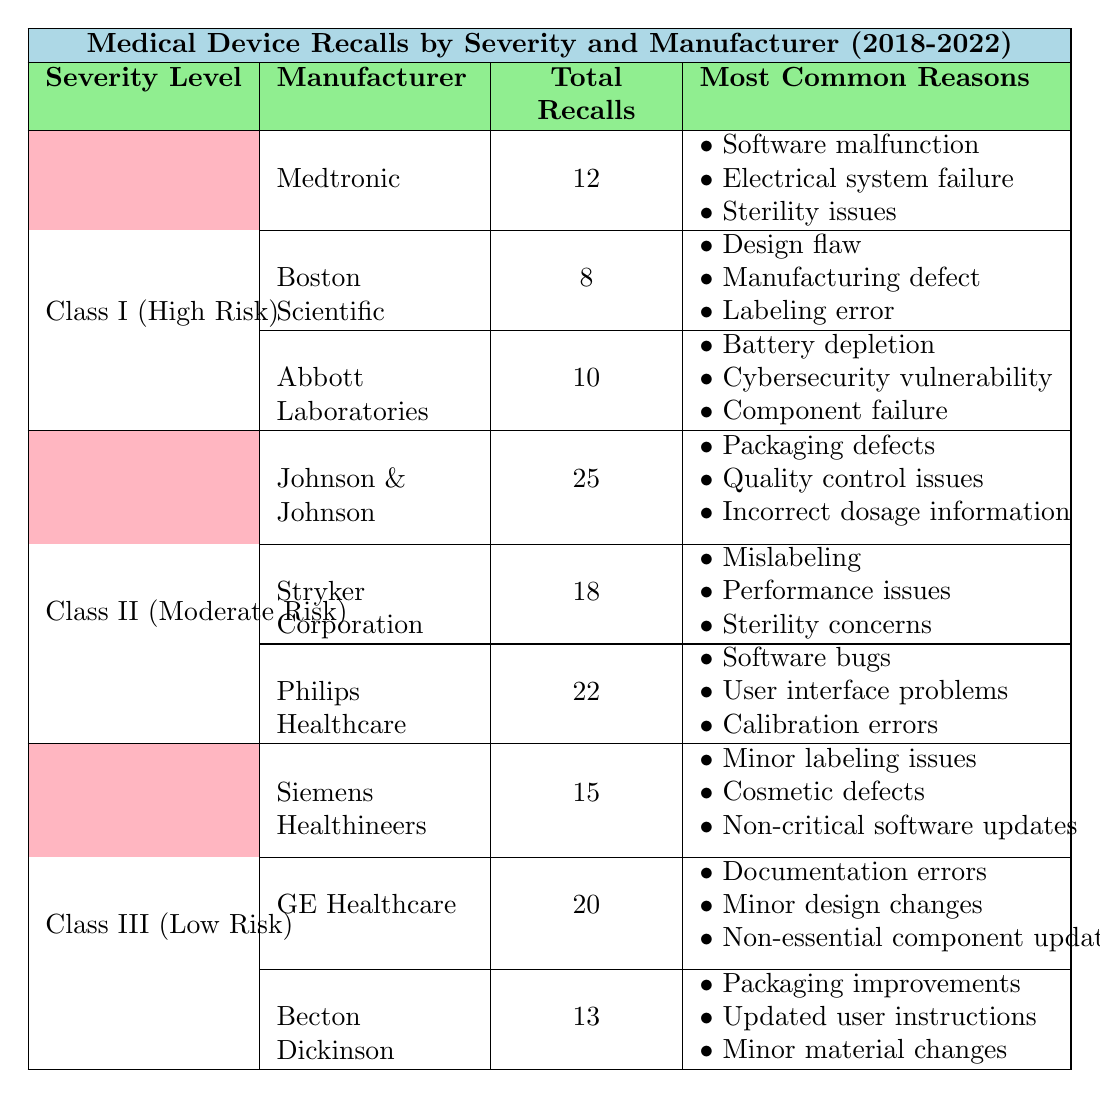What is the total number of Class I (High Risk) recalls from Medtronic? The table lists Medtronic under the Class I severity level, showing a total of 12 recalls attributed to them.
Answer: 12 Which manufacturer has the highest number of recalls in Class II (Moderate Risk)? In Class II, Johnson & Johnson has 25 recalls, which is more than Stryker Corporation (18) and Philips Healthcare (22).
Answer: Johnson & Johnson What is the most common reason for Abbott Laboratories' recalls? The table lists the most common reasons for Abbott Laboratories as battery depletion, cybersecurity vulnerability, and component failure. Since it lists three reasons, any can be deemed correct, but battery depletion is mentioned first.
Answer: Battery depletion How many recalls did GE Healthcare have compared to Siemens Healthineers? GE Healthcare had 20 recalls, while Siemens Healthineers had 15 recalls. The difference is 20 - 15 = 5 in favor of GE Healthcare.
Answer: 5 What is the average number of recalls for Class III (Low Risk) manufacturers? There are three manufacturers in Class III: Siemens Healthineers (15), GE Healthcare (20), and Becton Dickinson (13). Their total is 15 + 20 + 13 = 48. The average is 48/3 = 16.
Answer: 16 Did Abbott Laboratories have more recalls than Boston Scientific? Abbott Laboratories had 10 recalls and Boston Scientific had 8 recalls. Since 10 is greater than 8, the statement is true.
Answer: Yes Which severity level has the highest total number of recalls across all manufacturers? For Class II (Moderate Risk), the total recalls are 25 (Johnson & Johnson) + 18 (Stryker Corporation) + 22 (Philips Healthcare) = 65. For Class I, it's 12 + 8 + 10 = 30, and for Class III, it's 15 + 20 + 13 = 48. The highest total is from Class II with 65 recalls.
Answer: Class II (Moderate Risk) What percentage of total recalls in Class I (High Risk) were due to software-related issues? In Class I, Medtronic (12 recalls) had 3 software-related issues: software malfunction, electrical system failure, and sterility issues. Abbott Laboratories mentioned a cybersecurity vulnerability too. Thus, there are 4 software-related issues out of a total of 30 Class I recalls (12 + 8 + 10). The percentage of software-related issues is (4/30) * 100 = 13.33%.
Answer: 13.33% Which manufacturer tends to have sterility concerns as a recurring issue in their recalls, and in which severity level do they fall? Stryker Corporation has sterility concerns listed as one of their most common reasons for their Class II recalls.
Answer: Stryker Corporation in Class II (Moderate Risk) 